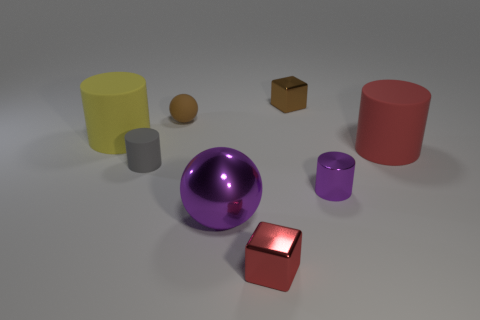Add 2 gray rubber objects. How many objects exist? 10 Subtract all blocks. How many objects are left? 6 Add 2 metallic cylinders. How many metallic cylinders are left? 3 Add 5 matte things. How many matte things exist? 9 Subtract 1 purple balls. How many objects are left? 7 Subtract all small gray things. Subtract all metallic cylinders. How many objects are left? 6 